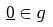<formula> <loc_0><loc_0><loc_500><loc_500>\underline { 0 } \in g</formula> 